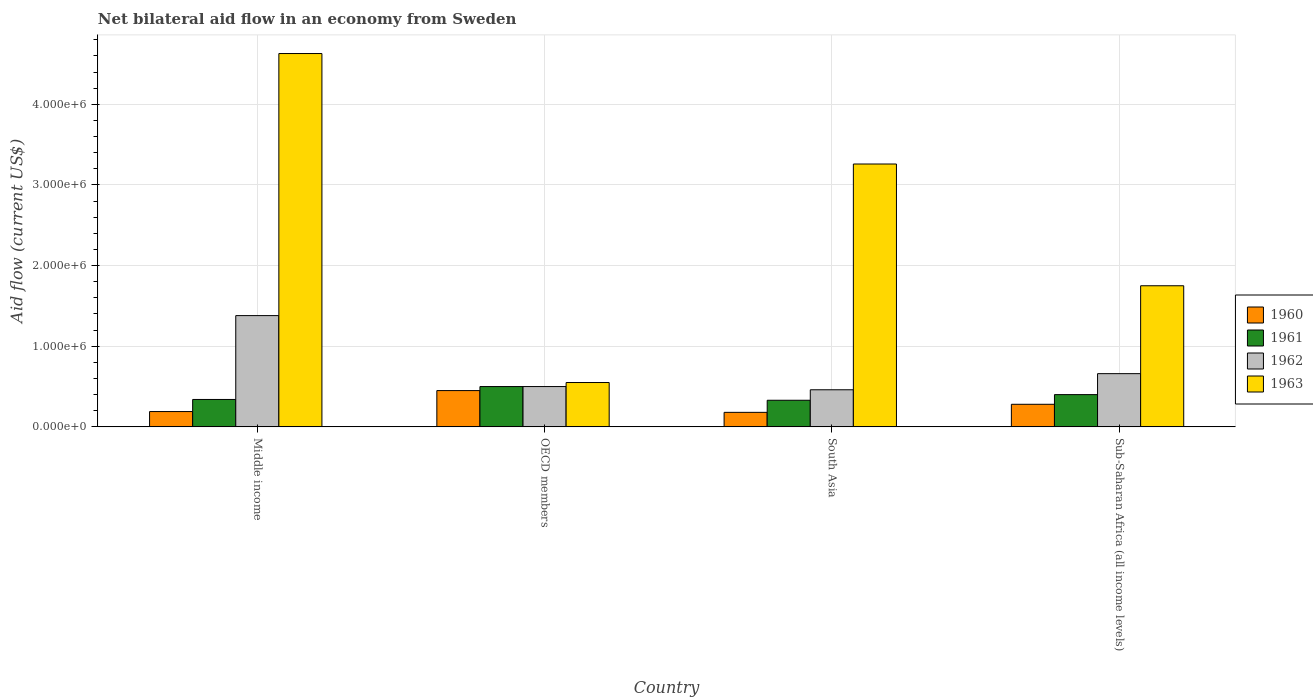How many different coloured bars are there?
Provide a succinct answer. 4. In how many cases, is the number of bars for a given country not equal to the number of legend labels?
Give a very brief answer. 0. What is the net bilateral aid flow in 1962 in Middle income?
Offer a terse response. 1.38e+06. Across all countries, what is the maximum net bilateral aid flow in 1960?
Provide a short and direct response. 4.50e+05. Across all countries, what is the minimum net bilateral aid flow in 1960?
Keep it short and to the point. 1.80e+05. In which country was the net bilateral aid flow in 1963 maximum?
Your answer should be compact. Middle income. What is the total net bilateral aid flow in 1963 in the graph?
Your answer should be compact. 1.02e+07. What is the difference between the net bilateral aid flow in 1963 in South Asia and that in Sub-Saharan Africa (all income levels)?
Offer a very short reply. 1.51e+06. What is the difference between the net bilateral aid flow in 1963 in Sub-Saharan Africa (all income levels) and the net bilateral aid flow in 1961 in OECD members?
Offer a very short reply. 1.25e+06. What is the average net bilateral aid flow in 1963 per country?
Give a very brief answer. 2.55e+06. What is the difference between the net bilateral aid flow of/in 1960 and net bilateral aid flow of/in 1962 in South Asia?
Offer a terse response. -2.80e+05. In how many countries, is the net bilateral aid flow in 1960 greater than 3400000 US$?
Offer a very short reply. 0. Is the net bilateral aid flow in 1961 in Middle income less than that in South Asia?
Provide a short and direct response. No. Is the difference between the net bilateral aid flow in 1960 in Middle income and OECD members greater than the difference between the net bilateral aid flow in 1962 in Middle income and OECD members?
Provide a short and direct response. No. What is the difference between the highest and the second highest net bilateral aid flow in 1960?
Your answer should be very brief. 2.60e+05. What is the difference between the highest and the lowest net bilateral aid flow in 1962?
Ensure brevity in your answer.  9.20e+05. In how many countries, is the net bilateral aid flow in 1962 greater than the average net bilateral aid flow in 1962 taken over all countries?
Your answer should be very brief. 1. What does the 3rd bar from the right in Sub-Saharan Africa (all income levels) represents?
Your answer should be very brief. 1961. Is it the case that in every country, the sum of the net bilateral aid flow in 1960 and net bilateral aid flow in 1963 is greater than the net bilateral aid flow in 1962?
Offer a very short reply. Yes. How many bars are there?
Offer a terse response. 16. How many legend labels are there?
Make the answer very short. 4. How are the legend labels stacked?
Your response must be concise. Vertical. What is the title of the graph?
Provide a short and direct response. Net bilateral aid flow in an economy from Sweden. What is the label or title of the X-axis?
Offer a terse response. Country. What is the label or title of the Y-axis?
Keep it short and to the point. Aid flow (current US$). What is the Aid flow (current US$) of 1960 in Middle income?
Offer a terse response. 1.90e+05. What is the Aid flow (current US$) of 1962 in Middle income?
Keep it short and to the point. 1.38e+06. What is the Aid flow (current US$) in 1963 in Middle income?
Give a very brief answer. 4.63e+06. What is the Aid flow (current US$) in 1960 in OECD members?
Keep it short and to the point. 4.50e+05. What is the Aid flow (current US$) of 1960 in South Asia?
Ensure brevity in your answer.  1.80e+05. What is the Aid flow (current US$) in 1961 in South Asia?
Make the answer very short. 3.30e+05. What is the Aid flow (current US$) in 1962 in South Asia?
Make the answer very short. 4.60e+05. What is the Aid flow (current US$) in 1963 in South Asia?
Provide a succinct answer. 3.26e+06. What is the Aid flow (current US$) of 1961 in Sub-Saharan Africa (all income levels)?
Give a very brief answer. 4.00e+05. What is the Aid flow (current US$) in 1962 in Sub-Saharan Africa (all income levels)?
Your response must be concise. 6.60e+05. What is the Aid flow (current US$) of 1963 in Sub-Saharan Africa (all income levels)?
Your answer should be compact. 1.75e+06. Across all countries, what is the maximum Aid flow (current US$) of 1961?
Make the answer very short. 5.00e+05. Across all countries, what is the maximum Aid flow (current US$) in 1962?
Keep it short and to the point. 1.38e+06. Across all countries, what is the maximum Aid flow (current US$) of 1963?
Provide a short and direct response. 4.63e+06. Across all countries, what is the minimum Aid flow (current US$) in 1961?
Your response must be concise. 3.30e+05. Across all countries, what is the minimum Aid flow (current US$) in 1962?
Your answer should be very brief. 4.60e+05. What is the total Aid flow (current US$) in 1960 in the graph?
Provide a short and direct response. 1.10e+06. What is the total Aid flow (current US$) in 1961 in the graph?
Make the answer very short. 1.57e+06. What is the total Aid flow (current US$) in 1963 in the graph?
Make the answer very short. 1.02e+07. What is the difference between the Aid flow (current US$) in 1962 in Middle income and that in OECD members?
Ensure brevity in your answer.  8.80e+05. What is the difference between the Aid flow (current US$) of 1963 in Middle income and that in OECD members?
Give a very brief answer. 4.08e+06. What is the difference between the Aid flow (current US$) in 1960 in Middle income and that in South Asia?
Offer a terse response. 10000. What is the difference between the Aid flow (current US$) in 1962 in Middle income and that in South Asia?
Provide a succinct answer. 9.20e+05. What is the difference between the Aid flow (current US$) of 1963 in Middle income and that in South Asia?
Keep it short and to the point. 1.37e+06. What is the difference between the Aid flow (current US$) of 1961 in Middle income and that in Sub-Saharan Africa (all income levels)?
Your answer should be compact. -6.00e+04. What is the difference between the Aid flow (current US$) in 1962 in Middle income and that in Sub-Saharan Africa (all income levels)?
Your response must be concise. 7.20e+05. What is the difference between the Aid flow (current US$) in 1963 in Middle income and that in Sub-Saharan Africa (all income levels)?
Offer a very short reply. 2.88e+06. What is the difference between the Aid flow (current US$) in 1963 in OECD members and that in South Asia?
Make the answer very short. -2.71e+06. What is the difference between the Aid flow (current US$) of 1961 in OECD members and that in Sub-Saharan Africa (all income levels)?
Offer a terse response. 1.00e+05. What is the difference between the Aid flow (current US$) in 1963 in OECD members and that in Sub-Saharan Africa (all income levels)?
Your answer should be compact. -1.20e+06. What is the difference between the Aid flow (current US$) in 1960 in South Asia and that in Sub-Saharan Africa (all income levels)?
Offer a terse response. -1.00e+05. What is the difference between the Aid flow (current US$) of 1961 in South Asia and that in Sub-Saharan Africa (all income levels)?
Your answer should be compact. -7.00e+04. What is the difference between the Aid flow (current US$) in 1962 in South Asia and that in Sub-Saharan Africa (all income levels)?
Your answer should be compact. -2.00e+05. What is the difference between the Aid flow (current US$) in 1963 in South Asia and that in Sub-Saharan Africa (all income levels)?
Make the answer very short. 1.51e+06. What is the difference between the Aid flow (current US$) in 1960 in Middle income and the Aid flow (current US$) in 1961 in OECD members?
Offer a terse response. -3.10e+05. What is the difference between the Aid flow (current US$) of 1960 in Middle income and the Aid flow (current US$) of 1962 in OECD members?
Your response must be concise. -3.10e+05. What is the difference between the Aid flow (current US$) in 1960 in Middle income and the Aid flow (current US$) in 1963 in OECD members?
Make the answer very short. -3.60e+05. What is the difference between the Aid flow (current US$) in 1961 in Middle income and the Aid flow (current US$) in 1963 in OECD members?
Offer a terse response. -2.10e+05. What is the difference between the Aid flow (current US$) of 1962 in Middle income and the Aid flow (current US$) of 1963 in OECD members?
Your answer should be compact. 8.30e+05. What is the difference between the Aid flow (current US$) in 1960 in Middle income and the Aid flow (current US$) in 1961 in South Asia?
Keep it short and to the point. -1.40e+05. What is the difference between the Aid flow (current US$) of 1960 in Middle income and the Aid flow (current US$) of 1962 in South Asia?
Offer a very short reply. -2.70e+05. What is the difference between the Aid flow (current US$) of 1960 in Middle income and the Aid flow (current US$) of 1963 in South Asia?
Offer a terse response. -3.07e+06. What is the difference between the Aid flow (current US$) in 1961 in Middle income and the Aid flow (current US$) in 1962 in South Asia?
Provide a short and direct response. -1.20e+05. What is the difference between the Aid flow (current US$) of 1961 in Middle income and the Aid flow (current US$) of 1963 in South Asia?
Give a very brief answer. -2.92e+06. What is the difference between the Aid flow (current US$) of 1962 in Middle income and the Aid flow (current US$) of 1963 in South Asia?
Provide a succinct answer. -1.88e+06. What is the difference between the Aid flow (current US$) of 1960 in Middle income and the Aid flow (current US$) of 1962 in Sub-Saharan Africa (all income levels)?
Keep it short and to the point. -4.70e+05. What is the difference between the Aid flow (current US$) in 1960 in Middle income and the Aid flow (current US$) in 1963 in Sub-Saharan Africa (all income levels)?
Your answer should be very brief. -1.56e+06. What is the difference between the Aid flow (current US$) of 1961 in Middle income and the Aid flow (current US$) of 1962 in Sub-Saharan Africa (all income levels)?
Your answer should be very brief. -3.20e+05. What is the difference between the Aid flow (current US$) in 1961 in Middle income and the Aid flow (current US$) in 1963 in Sub-Saharan Africa (all income levels)?
Your response must be concise. -1.41e+06. What is the difference between the Aid flow (current US$) of 1962 in Middle income and the Aid flow (current US$) of 1963 in Sub-Saharan Africa (all income levels)?
Ensure brevity in your answer.  -3.70e+05. What is the difference between the Aid flow (current US$) of 1960 in OECD members and the Aid flow (current US$) of 1961 in South Asia?
Your answer should be compact. 1.20e+05. What is the difference between the Aid flow (current US$) in 1960 in OECD members and the Aid flow (current US$) in 1962 in South Asia?
Keep it short and to the point. -10000. What is the difference between the Aid flow (current US$) of 1960 in OECD members and the Aid flow (current US$) of 1963 in South Asia?
Keep it short and to the point. -2.81e+06. What is the difference between the Aid flow (current US$) of 1961 in OECD members and the Aid flow (current US$) of 1962 in South Asia?
Keep it short and to the point. 4.00e+04. What is the difference between the Aid flow (current US$) of 1961 in OECD members and the Aid flow (current US$) of 1963 in South Asia?
Give a very brief answer. -2.76e+06. What is the difference between the Aid flow (current US$) in 1962 in OECD members and the Aid flow (current US$) in 1963 in South Asia?
Your answer should be very brief. -2.76e+06. What is the difference between the Aid flow (current US$) in 1960 in OECD members and the Aid flow (current US$) in 1961 in Sub-Saharan Africa (all income levels)?
Give a very brief answer. 5.00e+04. What is the difference between the Aid flow (current US$) in 1960 in OECD members and the Aid flow (current US$) in 1963 in Sub-Saharan Africa (all income levels)?
Your response must be concise. -1.30e+06. What is the difference between the Aid flow (current US$) of 1961 in OECD members and the Aid flow (current US$) of 1963 in Sub-Saharan Africa (all income levels)?
Your response must be concise. -1.25e+06. What is the difference between the Aid flow (current US$) in 1962 in OECD members and the Aid flow (current US$) in 1963 in Sub-Saharan Africa (all income levels)?
Make the answer very short. -1.25e+06. What is the difference between the Aid flow (current US$) of 1960 in South Asia and the Aid flow (current US$) of 1961 in Sub-Saharan Africa (all income levels)?
Offer a terse response. -2.20e+05. What is the difference between the Aid flow (current US$) in 1960 in South Asia and the Aid flow (current US$) in 1962 in Sub-Saharan Africa (all income levels)?
Give a very brief answer. -4.80e+05. What is the difference between the Aid flow (current US$) in 1960 in South Asia and the Aid flow (current US$) in 1963 in Sub-Saharan Africa (all income levels)?
Your answer should be compact. -1.57e+06. What is the difference between the Aid flow (current US$) of 1961 in South Asia and the Aid flow (current US$) of 1962 in Sub-Saharan Africa (all income levels)?
Give a very brief answer. -3.30e+05. What is the difference between the Aid flow (current US$) of 1961 in South Asia and the Aid flow (current US$) of 1963 in Sub-Saharan Africa (all income levels)?
Provide a succinct answer. -1.42e+06. What is the difference between the Aid flow (current US$) in 1962 in South Asia and the Aid flow (current US$) in 1963 in Sub-Saharan Africa (all income levels)?
Your response must be concise. -1.29e+06. What is the average Aid flow (current US$) in 1960 per country?
Offer a terse response. 2.75e+05. What is the average Aid flow (current US$) in 1961 per country?
Make the answer very short. 3.92e+05. What is the average Aid flow (current US$) in 1962 per country?
Offer a terse response. 7.50e+05. What is the average Aid flow (current US$) of 1963 per country?
Provide a short and direct response. 2.55e+06. What is the difference between the Aid flow (current US$) in 1960 and Aid flow (current US$) in 1962 in Middle income?
Make the answer very short. -1.19e+06. What is the difference between the Aid flow (current US$) in 1960 and Aid flow (current US$) in 1963 in Middle income?
Make the answer very short. -4.44e+06. What is the difference between the Aid flow (current US$) of 1961 and Aid flow (current US$) of 1962 in Middle income?
Your answer should be very brief. -1.04e+06. What is the difference between the Aid flow (current US$) of 1961 and Aid flow (current US$) of 1963 in Middle income?
Provide a succinct answer. -4.29e+06. What is the difference between the Aid flow (current US$) in 1962 and Aid flow (current US$) in 1963 in Middle income?
Provide a short and direct response. -3.25e+06. What is the difference between the Aid flow (current US$) in 1960 and Aid flow (current US$) in 1962 in OECD members?
Keep it short and to the point. -5.00e+04. What is the difference between the Aid flow (current US$) of 1960 and Aid flow (current US$) of 1963 in OECD members?
Your answer should be very brief. -1.00e+05. What is the difference between the Aid flow (current US$) in 1961 and Aid flow (current US$) in 1962 in OECD members?
Your answer should be very brief. 0. What is the difference between the Aid flow (current US$) in 1961 and Aid flow (current US$) in 1963 in OECD members?
Your answer should be very brief. -5.00e+04. What is the difference between the Aid flow (current US$) of 1962 and Aid flow (current US$) of 1963 in OECD members?
Offer a terse response. -5.00e+04. What is the difference between the Aid flow (current US$) of 1960 and Aid flow (current US$) of 1962 in South Asia?
Offer a terse response. -2.80e+05. What is the difference between the Aid flow (current US$) of 1960 and Aid flow (current US$) of 1963 in South Asia?
Your answer should be compact. -3.08e+06. What is the difference between the Aid flow (current US$) in 1961 and Aid flow (current US$) in 1962 in South Asia?
Make the answer very short. -1.30e+05. What is the difference between the Aid flow (current US$) in 1961 and Aid flow (current US$) in 1963 in South Asia?
Provide a succinct answer. -2.93e+06. What is the difference between the Aid flow (current US$) in 1962 and Aid flow (current US$) in 1963 in South Asia?
Keep it short and to the point. -2.80e+06. What is the difference between the Aid flow (current US$) of 1960 and Aid flow (current US$) of 1961 in Sub-Saharan Africa (all income levels)?
Your answer should be very brief. -1.20e+05. What is the difference between the Aid flow (current US$) of 1960 and Aid flow (current US$) of 1962 in Sub-Saharan Africa (all income levels)?
Give a very brief answer. -3.80e+05. What is the difference between the Aid flow (current US$) in 1960 and Aid flow (current US$) in 1963 in Sub-Saharan Africa (all income levels)?
Ensure brevity in your answer.  -1.47e+06. What is the difference between the Aid flow (current US$) in 1961 and Aid flow (current US$) in 1963 in Sub-Saharan Africa (all income levels)?
Give a very brief answer. -1.35e+06. What is the difference between the Aid flow (current US$) in 1962 and Aid flow (current US$) in 1963 in Sub-Saharan Africa (all income levels)?
Offer a terse response. -1.09e+06. What is the ratio of the Aid flow (current US$) of 1960 in Middle income to that in OECD members?
Your response must be concise. 0.42. What is the ratio of the Aid flow (current US$) of 1961 in Middle income to that in OECD members?
Ensure brevity in your answer.  0.68. What is the ratio of the Aid flow (current US$) in 1962 in Middle income to that in OECD members?
Keep it short and to the point. 2.76. What is the ratio of the Aid flow (current US$) in 1963 in Middle income to that in OECD members?
Your response must be concise. 8.42. What is the ratio of the Aid flow (current US$) of 1960 in Middle income to that in South Asia?
Your response must be concise. 1.06. What is the ratio of the Aid flow (current US$) in 1961 in Middle income to that in South Asia?
Provide a short and direct response. 1.03. What is the ratio of the Aid flow (current US$) in 1962 in Middle income to that in South Asia?
Make the answer very short. 3. What is the ratio of the Aid flow (current US$) of 1963 in Middle income to that in South Asia?
Make the answer very short. 1.42. What is the ratio of the Aid flow (current US$) in 1960 in Middle income to that in Sub-Saharan Africa (all income levels)?
Your answer should be very brief. 0.68. What is the ratio of the Aid flow (current US$) in 1962 in Middle income to that in Sub-Saharan Africa (all income levels)?
Make the answer very short. 2.09. What is the ratio of the Aid flow (current US$) in 1963 in Middle income to that in Sub-Saharan Africa (all income levels)?
Provide a succinct answer. 2.65. What is the ratio of the Aid flow (current US$) of 1960 in OECD members to that in South Asia?
Offer a very short reply. 2.5. What is the ratio of the Aid flow (current US$) of 1961 in OECD members to that in South Asia?
Your answer should be compact. 1.52. What is the ratio of the Aid flow (current US$) of 1962 in OECD members to that in South Asia?
Keep it short and to the point. 1.09. What is the ratio of the Aid flow (current US$) in 1963 in OECD members to that in South Asia?
Offer a very short reply. 0.17. What is the ratio of the Aid flow (current US$) in 1960 in OECD members to that in Sub-Saharan Africa (all income levels)?
Ensure brevity in your answer.  1.61. What is the ratio of the Aid flow (current US$) in 1962 in OECD members to that in Sub-Saharan Africa (all income levels)?
Provide a succinct answer. 0.76. What is the ratio of the Aid flow (current US$) in 1963 in OECD members to that in Sub-Saharan Africa (all income levels)?
Give a very brief answer. 0.31. What is the ratio of the Aid flow (current US$) of 1960 in South Asia to that in Sub-Saharan Africa (all income levels)?
Give a very brief answer. 0.64. What is the ratio of the Aid flow (current US$) of 1961 in South Asia to that in Sub-Saharan Africa (all income levels)?
Ensure brevity in your answer.  0.82. What is the ratio of the Aid flow (current US$) in 1962 in South Asia to that in Sub-Saharan Africa (all income levels)?
Offer a very short reply. 0.7. What is the ratio of the Aid flow (current US$) of 1963 in South Asia to that in Sub-Saharan Africa (all income levels)?
Give a very brief answer. 1.86. What is the difference between the highest and the second highest Aid flow (current US$) in 1960?
Ensure brevity in your answer.  1.70e+05. What is the difference between the highest and the second highest Aid flow (current US$) of 1961?
Offer a terse response. 1.00e+05. What is the difference between the highest and the second highest Aid flow (current US$) of 1962?
Provide a succinct answer. 7.20e+05. What is the difference between the highest and the second highest Aid flow (current US$) of 1963?
Keep it short and to the point. 1.37e+06. What is the difference between the highest and the lowest Aid flow (current US$) in 1960?
Provide a short and direct response. 2.70e+05. What is the difference between the highest and the lowest Aid flow (current US$) in 1962?
Provide a succinct answer. 9.20e+05. What is the difference between the highest and the lowest Aid flow (current US$) of 1963?
Provide a succinct answer. 4.08e+06. 